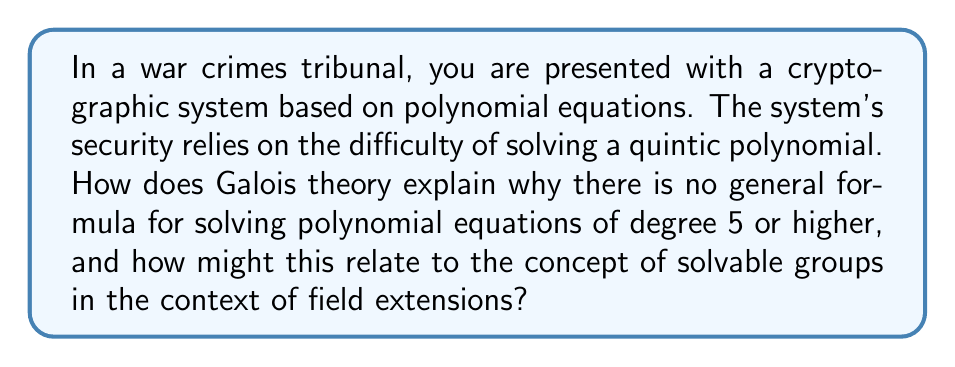What is the answer to this math problem? To understand this, let's break it down step-by-step:

1) Galois theory establishes a connection between field extensions and group theory. For a polynomial $f(x)$ over a field $F$, we consider its splitting field $E$ over $F$.

2) The Galois group $Gal(E/F)$ is the group of automorphisms of $E$ that fix $F$. This group reflects the symmetries of the roots of $f(x)$.

3) For a polynomial of degree $n$, its Galois group is a subgroup of the symmetric group $S_n$.

4) A polynomial is solvable by radicals if and only if its Galois group is a solvable group. A group $G$ is solvable if it has a normal series:

   $$G = G_0 \triangleright G_1 \triangleright ... \triangleright G_n = \{e\}$$

   where each quotient group $G_i/G_{i+1}$ is abelian.

5) For $n \leq 4$, the symmetric group $S_n$ is solvable, which is why we have general formulas for polynomials up to degree 4.

6) However, for $n \geq 5$, $S_n$ is not solvable. This means there exist quintic polynomials whose Galois group is $S_5$, which are not solvable by radicals.

7) In the context of field extensions, this means that for a general quintic polynomial, we cannot construct a tower of field extensions where each extension is obtained by adjoining an $n$-th root.

8) For cryptographic applications, this implies that certain systems based on quintic or higher degree polynomials cannot be easily broken by algebraic methods, providing a level of security.
Answer: Galois theory shows quintic equations aren't generally solvable by radicals because $S_5$ isn't a solvable group, implying no general radical solution exists for degree $\geq 5$ polynomials. 